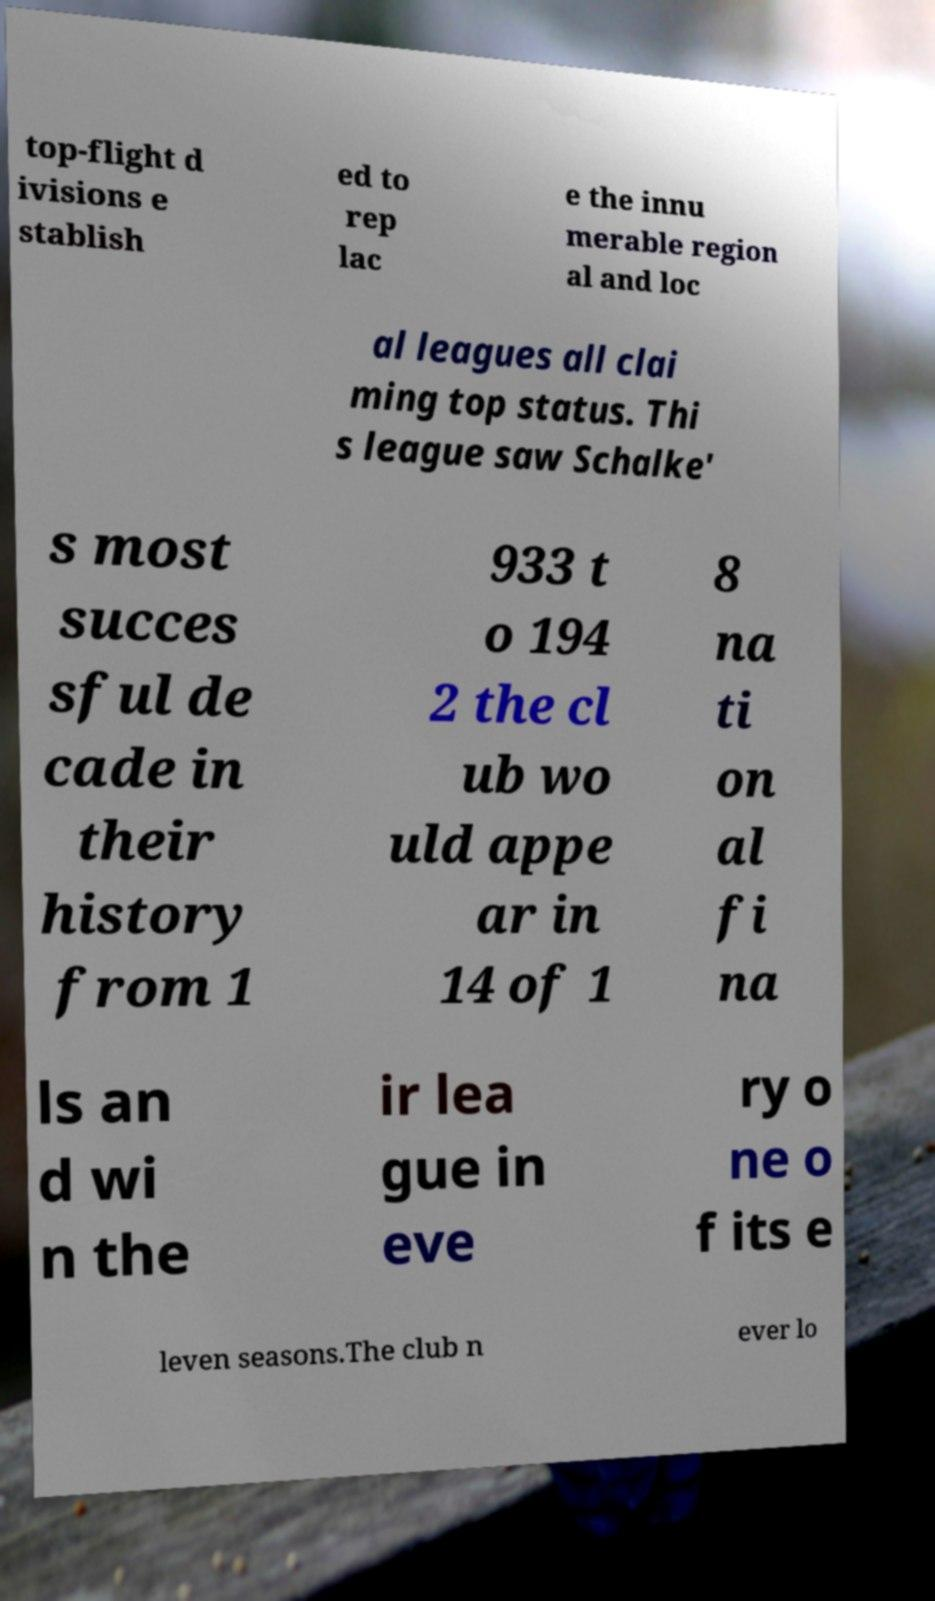Please read and relay the text visible in this image. What does it say? top-flight d ivisions e stablish ed to rep lac e the innu merable region al and loc al leagues all clai ming top status. Thi s league saw Schalke' s most succes sful de cade in their history from 1 933 t o 194 2 the cl ub wo uld appe ar in 14 of 1 8 na ti on al fi na ls an d wi n the ir lea gue in eve ry o ne o f its e leven seasons.The club n ever lo 